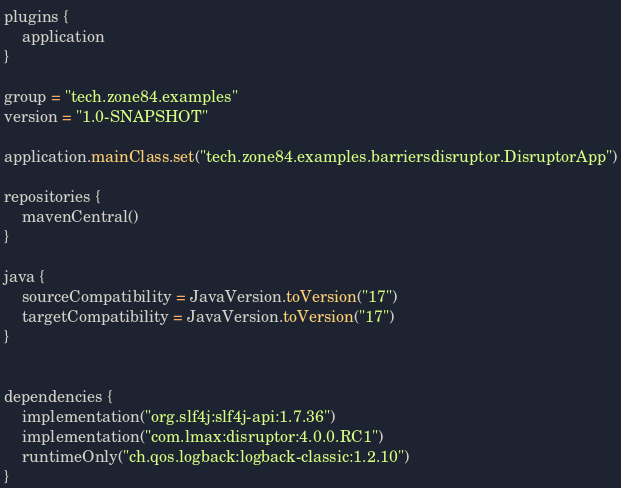<code> <loc_0><loc_0><loc_500><loc_500><_Kotlin_>plugins {
    application
}

group = "tech.zone84.examples"
version = "1.0-SNAPSHOT"

application.mainClass.set("tech.zone84.examples.barriersdisruptor.DisruptorApp")

repositories {
    mavenCentral()
}

java {
    sourceCompatibility = JavaVersion.toVersion("17")
    targetCompatibility = JavaVersion.toVersion("17")
}


dependencies {
    implementation("org.slf4j:slf4j-api:1.7.36")
    implementation("com.lmax:disruptor:4.0.0.RC1")
    runtimeOnly("ch.qos.logback:logback-classic:1.2.10")
}
</code> 